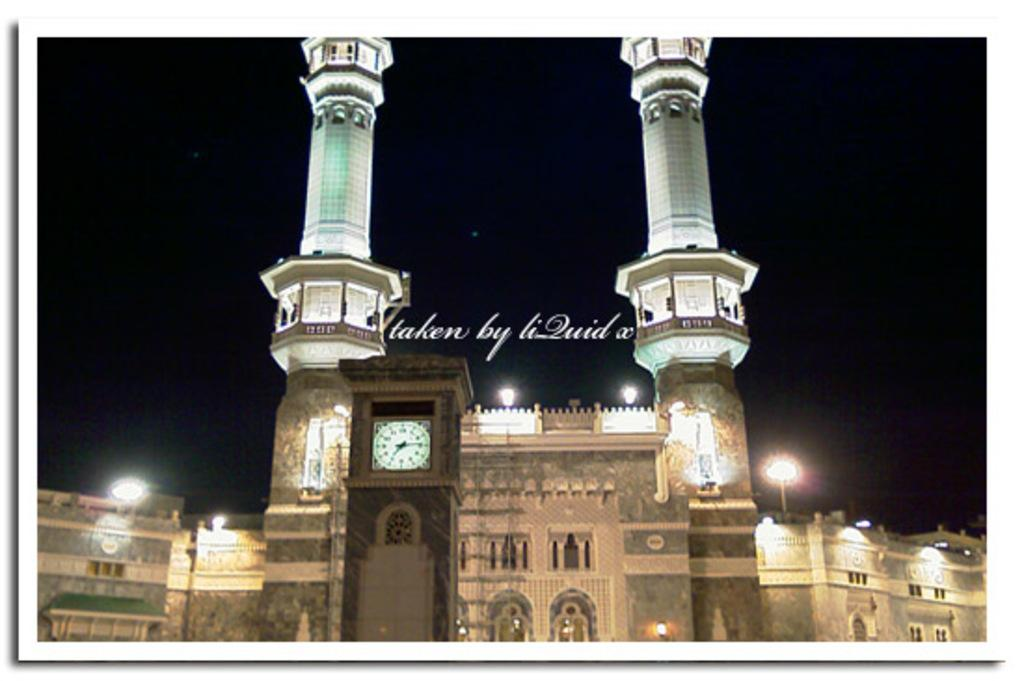What type of structure is in the image? There is a building in the image. Can you describe a specific feature of the building? There is a clock on a wall in the image. What else can be seen in the image besides the building? There are lights visible in the image. Is there any text present in the image? Yes, there is text present in the image. How would you describe the overall lighting in the image? The background of the image is dark. What type of approval is required for the payment in the image? There is no payment or approval process depicted in the image; it only features a building, a clock, lights, and text. 